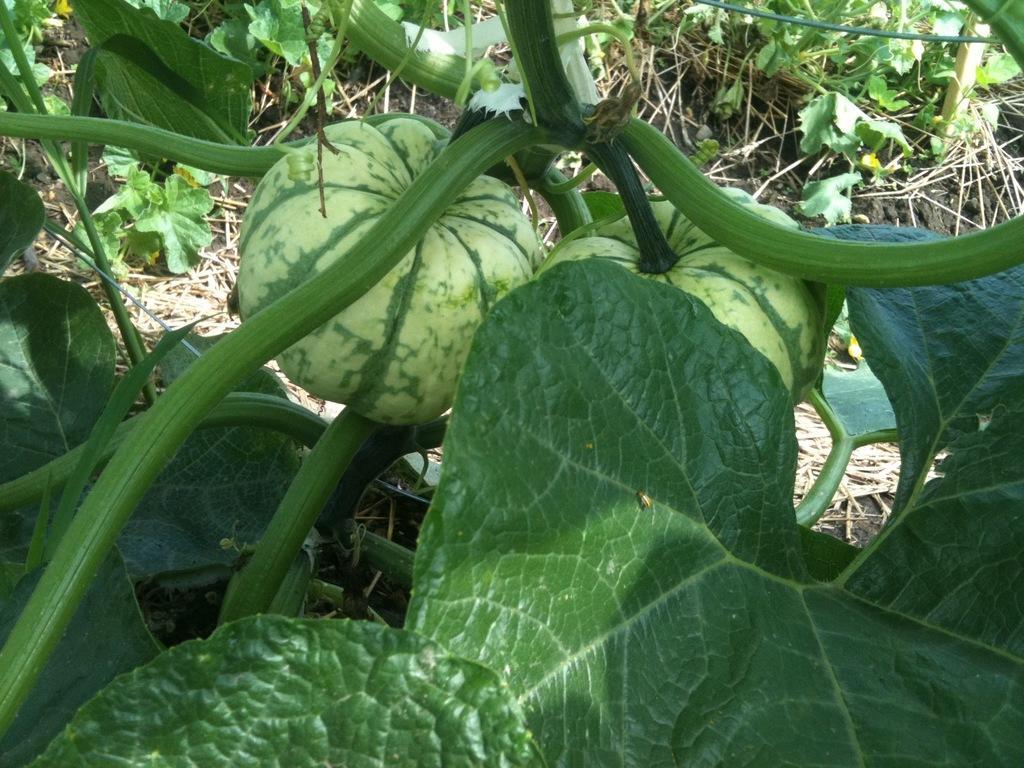Can you describe this image briefly? In the image there are pumpkin plants on the land. 